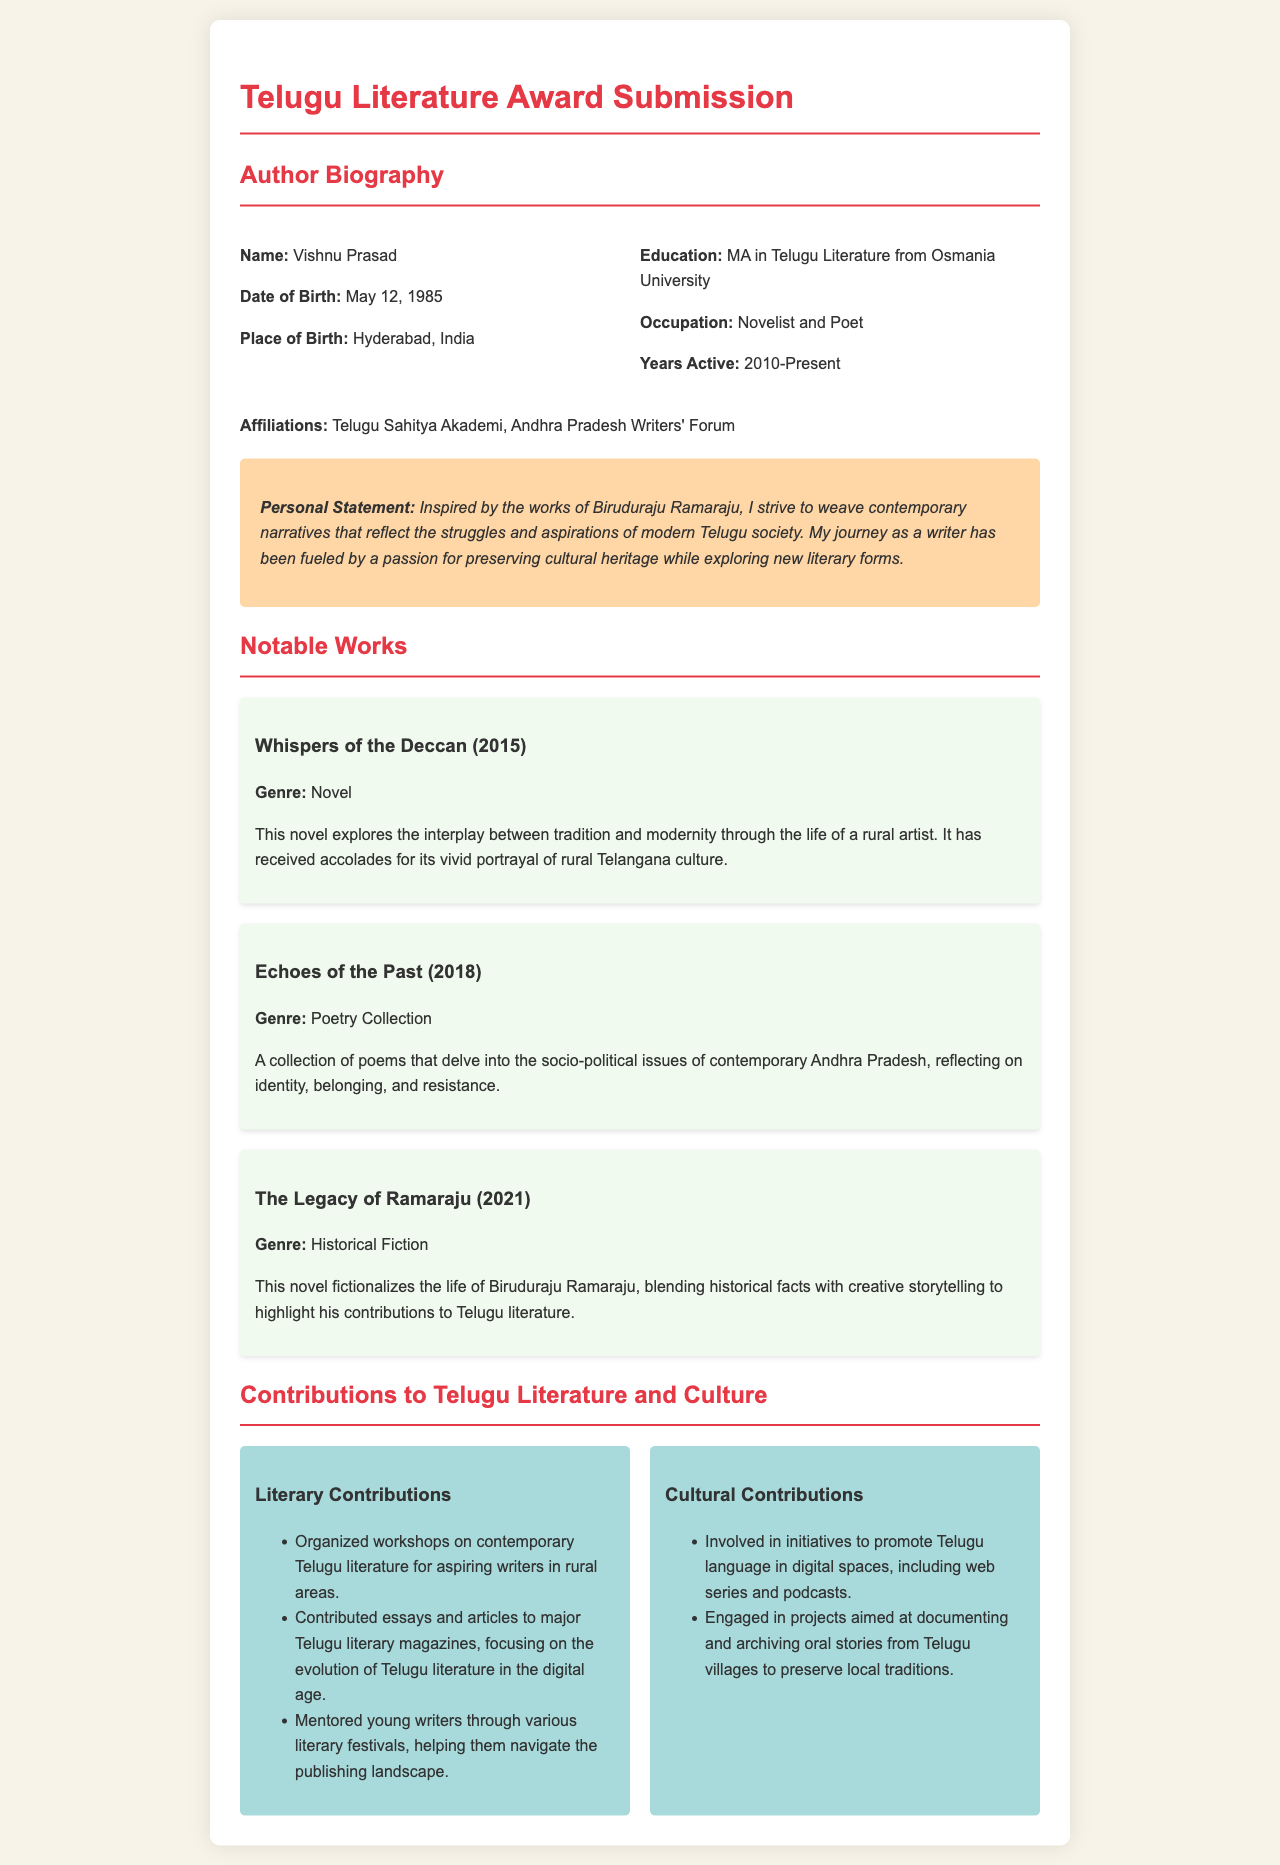What is the author's name? The author's name is stated in the biography section of the document.
Answer: Vishnu Prasad When was the author born? The date of birth is provided in the author biography.
Answer: May 12, 1985 What degree does the author hold? The education background mentions the author's highest qualification.
Answer: MA in Telugu Literature What is the genre of "Whispers of the Deccan"? The genre of notable works is specified in their descriptions.
Answer: Novel Which organization is the author affiliated with? The author's affiliations are listed in the biography section.
Answer: Telugu Sahitya Akademi How many years has the author been active? This information can be calculated from the years active mentioned in the biography.
Answer: 13 years What is the personal statement's main inspiration for the author? The personal statement expresses the author's inspiration behind their writing.
Answer: Biruduraju Ramaraju What type of work does the author engage in for aspiring writers? The contributions section mentions various activities related to mentoring writers.
Answer: Workshops What is the title of the author's poetry collection? The notable works section lists the titles of the author's published works.
Answer: Echoes of the Past 